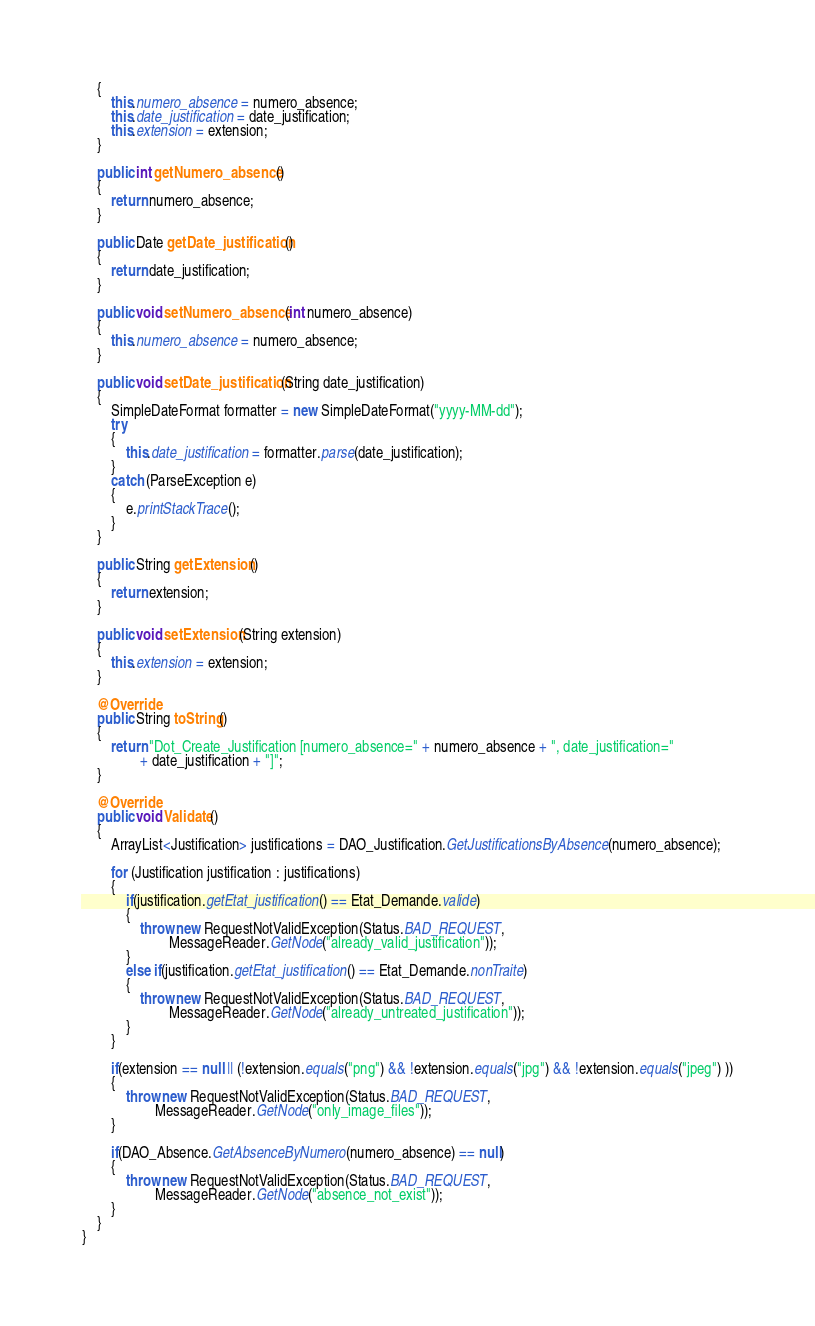<code> <loc_0><loc_0><loc_500><loc_500><_Java_>	{
		this.numero_absence = numero_absence;
		this.date_justification = date_justification;
		this.extension = extension;
	}

	public int getNumero_absence()
	{
		return numero_absence;
	}

	public Date getDate_justification()
	{
		return date_justification;
	}

	public void setNumero_absence(int numero_absence)
	{
		this.numero_absence = numero_absence;
	}
	
	public void setDate_justification(String date_justification)
	{
		SimpleDateFormat formatter = new SimpleDateFormat("yyyy-MM-dd");
		try
		{
			this.date_justification = formatter.parse(date_justification);
		}
		catch (ParseException e)
		{
			e.printStackTrace();
		}		
	}
	
	public String getExtension()
	{
		return extension;
	}

	public void setExtension(String extension)
	{
		this.extension = extension;
	}

	@Override
	public String toString()
	{
		return "Dot_Create_Justification [numero_absence=" + numero_absence + ", date_justification="
				+ date_justification + "]";
	}

	@Override
	public void Validate()
	{		
		ArrayList<Justification> justifications = DAO_Justification.GetJustificationsByAbsence(numero_absence);
		
		for (Justification justification : justifications)
		{
			if(justification.getEtat_justification() == Etat_Demande.valide)
			{
				throw new RequestNotValidException(Status.BAD_REQUEST,
						MessageReader.GetNode("already_valid_justification"));
			}
			else if(justification.getEtat_justification() == Etat_Demande.nonTraite)
			{
				throw new RequestNotValidException(Status.BAD_REQUEST, 
						MessageReader.GetNode("already_untreated_justification"));
			}
		}
		
		if(extension == null || (!extension.equals("png") && !extension.equals("jpg") && !extension.equals("jpeg") ))
		{
			throw new RequestNotValidException(Status.BAD_REQUEST, 
					MessageReader.GetNode("only_image_files"));
		}
		
		if(DAO_Absence.GetAbsenceByNumero(numero_absence) == null)
		{
			throw new RequestNotValidException(Status.BAD_REQUEST,
					MessageReader.GetNode("absence_not_exist"));
		}
	}
}
</code> 